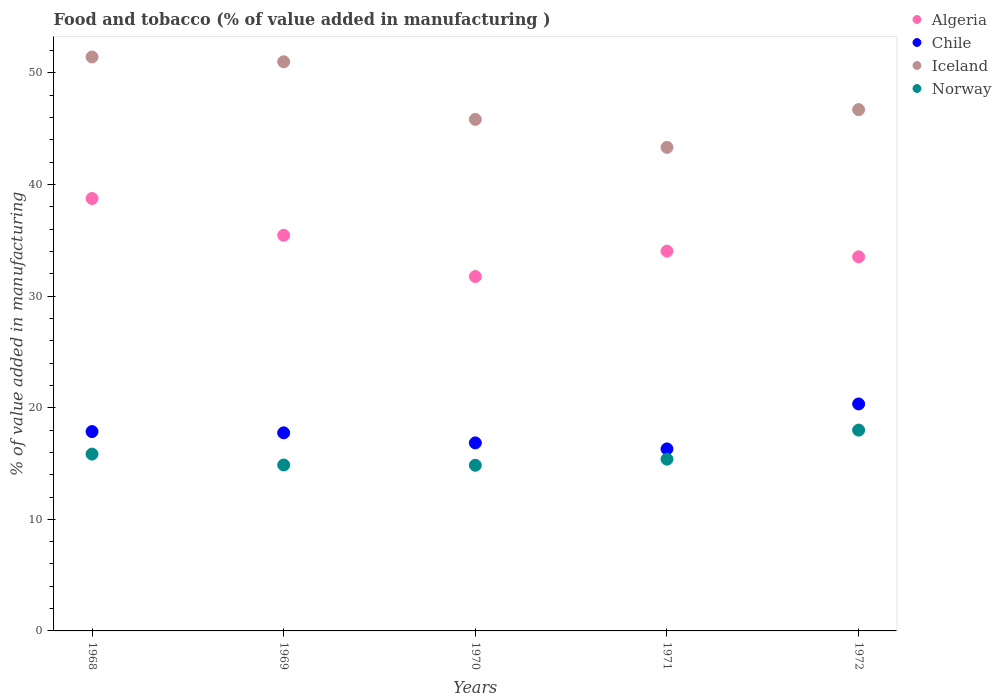What is the value added in manufacturing food and tobacco in Algeria in 1969?
Provide a short and direct response. 35.46. Across all years, what is the maximum value added in manufacturing food and tobacco in Norway?
Offer a terse response. 18. Across all years, what is the minimum value added in manufacturing food and tobacco in Norway?
Your answer should be very brief. 14.84. In which year was the value added in manufacturing food and tobacco in Chile maximum?
Offer a very short reply. 1972. What is the total value added in manufacturing food and tobacco in Norway in the graph?
Ensure brevity in your answer.  78.95. What is the difference between the value added in manufacturing food and tobacco in Algeria in 1969 and that in 1971?
Your answer should be very brief. 1.42. What is the difference between the value added in manufacturing food and tobacco in Iceland in 1972 and the value added in manufacturing food and tobacco in Norway in 1968?
Give a very brief answer. 30.87. What is the average value added in manufacturing food and tobacco in Iceland per year?
Ensure brevity in your answer.  47.67. In the year 1968, what is the difference between the value added in manufacturing food and tobacco in Algeria and value added in manufacturing food and tobacco in Norway?
Keep it short and to the point. 22.9. In how many years, is the value added in manufacturing food and tobacco in Norway greater than 26 %?
Your answer should be compact. 0. What is the ratio of the value added in manufacturing food and tobacco in Chile in 1968 to that in 1971?
Your answer should be compact. 1.1. Is the difference between the value added in manufacturing food and tobacco in Algeria in 1969 and 1970 greater than the difference between the value added in manufacturing food and tobacco in Norway in 1969 and 1970?
Your answer should be very brief. Yes. What is the difference between the highest and the second highest value added in manufacturing food and tobacco in Algeria?
Your answer should be very brief. 3.29. What is the difference between the highest and the lowest value added in manufacturing food and tobacco in Iceland?
Give a very brief answer. 8.1. In how many years, is the value added in manufacturing food and tobacco in Norway greater than the average value added in manufacturing food and tobacco in Norway taken over all years?
Your answer should be very brief. 2. Is the sum of the value added in manufacturing food and tobacco in Algeria in 1968 and 1969 greater than the maximum value added in manufacturing food and tobacco in Norway across all years?
Keep it short and to the point. Yes. Is it the case that in every year, the sum of the value added in manufacturing food and tobacco in Chile and value added in manufacturing food and tobacco in Iceland  is greater than the sum of value added in manufacturing food and tobacco in Norway and value added in manufacturing food and tobacco in Algeria?
Ensure brevity in your answer.  Yes. Is it the case that in every year, the sum of the value added in manufacturing food and tobacco in Norway and value added in manufacturing food and tobacco in Chile  is greater than the value added in manufacturing food and tobacco in Iceland?
Give a very brief answer. No. Does the value added in manufacturing food and tobacco in Algeria monotonically increase over the years?
Offer a terse response. No. Is the value added in manufacturing food and tobacco in Iceland strictly greater than the value added in manufacturing food and tobacco in Chile over the years?
Provide a succinct answer. Yes. Are the values on the major ticks of Y-axis written in scientific E-notation?
Provide a succinct answer. No. Does the graph contain any zero values?
Keep it short and to the point. No. Does the graph contain grids?
Your answer should be compact. No. Where does the legend appear in the graph?
Provide a succinct answer. Top right. What is the title of the graph?
Provide a succinct answer. Food and tobacco (% of value added in manufacturing ). What is the label or title of the X-axis?
Keep it short and to the point. Years. What is the label or title of the Y-axis?
Ensure brevity in your answer.  % of value added in manufacturing. What is the % of value added in manufacturing of Algeria in 1968?
Ensure brevity in your answer.  38.75. What is the % of value added in manufacturing in Chile in 1968?
Your response must be concise. 17.87. What is the % of value added in manufacturing of Iceland in 1968?
Keep it short and to the point. 51.43. What is the % of value added in manufacturing of Norway in 1968?
Give a very brief answer. 15.85. What is the % of value added in manufacturing of Algeria in 1969?
Your response must be concise. 35.46. What is the % of value added in manufacturing of Chile in 1969?
Offer a very short reply. 17.75. What is the % of value added in manufacturing in Iceland in 1969?
Keep it short and to the point. 51. What is the % of value added in manufacturing in Norway in 1969?
Give a very brief answer. 14.87. What is the % of value added in manufacturing in Algeria in 1970?
Your response must be concise. 31.76. What is the % of value added in manufacturing in Chile in 1970?
Your answer should be very brief. 16.85. What is the % of value added in manufacturing of Iceland in 1970?
Give a very brief answer. 45.84. What is the % of value added in manufacturing of Norway in 1970?
Make the answer very short. 14.84. What is the % of value added in manufacturing of Algeria in 1971?
Make the answer very short. 34.04. What is the % of value added in manufacturing of Chile in 1971?
Give a very brief answer. 16.31. What is the % of value added in manufacturing of Iceland in 1971?
Offer a very short reply. 43.33. What is the % of value added in manufacturing in Norway in 1971?
Your answer should be compact. 15.39. What is the % of value added in manufacturing in Algeria in 1972?
Ensure brevity in your answer.  33.52. What is the % of value added in manufacturing in Chile in 1972?
Your response must be concise. 20.34. What is the % of value added in manufacturing of Iceland in 1972?
Your response must be concise. 46.72. What is the % of value added in manufacturing of Norway in 1972?
Keep it short and to the point. 18. Across all years, what is the maximum % of value added in manufacturing in Algeria?
Provide a succinct answer. 38.75. Across all years, what is the maximum % of value added in manufacturing in Chile?
Provide a short and direct response. 20.34. Across all years, what is the maximum % of value added in manufacturing of Iceland?
Provide a short and direct response. 51.43. Across all years, what is the maximum % of value added in manufacturing in Norway?
Your answer should be very brief. 18. Across all years, what is the minimum % of value added in manufacturing of Algeria?
Your answer should be very brief. 31.76. Across all years, what is the minimum % of value added in manufacturing in Chile?
Provide a short and direct response. 16.31. Across all years, what is the minimum % of value added in manufacturing of Iceland?
Make the answer very short. 43.33. Across all years, what is the minimum % of value added in manufacturing in Norway?
Ensure brevity in your answer.  14.84. What is the total % of value added in manufacturing in Algeria in the graph?
Make the answer very short. 173.52. What is the total % of value added in manufacturing in Chile in the graph?
Offer a very short reply. 89.12. What is the total % of value added in manufacturing in Iceland in the graph?
Offer a very short reply. 238.33. What is the total % of value added in manufacturing of Norway in the graph?
Give a very brief answer. 78.95. What is the difference between the % of value added in manufacturing in Algeria in 1968 and that in 1969?
Provide a short and direct response. 3.29. What is the difference between the % of value added in manufacturing in Chile in 1968 and that in 1969?
Ensure brevity in your answer.  0.11. What is the difference between the % of value added in manufacturing in Iceland in 1968 and that in 1969?
Provide a succinct answer. 0.43. What is the difference between the % of value added in manufacturing of Norway in 1968 and that in 1969?
Offer a very short reply. 0.98. What is the difference between the % of value added in manufacturing in Algeria in 1968 and that in 1970?
Your response must be concise. 6.99. What is the difference between the % of value added in manufacturing in Chile in 1968 and that in 1970?
Keep it short and to the point. 1.01. What is the difference between the % of value added in manufacturing of Iceland in 1968 and that in 1970?
Offer a terse response. 5.59. What is the difference between the % of value added in manufacturing in Norway in 1968 and that in 1970?
Ensure brevity in your answer.  1. What is the difference between the % of value added in manufacturing of Algeria in 1968 and that in 1971?
Provide a short and direct response. 4.71. What is the difference between the % of value added in manufacturing of Chile in 1968 and that in 1971?
Offer a terse response. 1.55. What is the difference between the % of value added in manufacturing in Iceland in 1968 and that in 1971?
Provide a succinct answer. 8.1. What is the difference between the % of value added in manufacturing in Norway in 1968 and that in 1971?
Your answer should be very brief. 0.45. What is the difference between the % of value added in manufacturing in Algeria in 1968 and that in 1972?
Give a very brief answer. 5.23. What is the difference between the % of value added in manufacturing in Chile in 1968 and that in 1972?
Your response must be concise. -2.48. What is the difference between the % of value added in manufacturing of Iceland in 1968 and that in 1972?
Offer a terse response. 4.72. What is the difference between the % of value added in manufacturing of Norway in 1968 and that in 1972?
Provide a succinct answer. -2.15. What is the difference between the % of value added in manufacturing in Algeria in 1969 and that in 1970?
Your response must be concise. 3.7. What is the difference between the % of value added in manufacturing in Chile in 1969 and that in 1970?
Your response must be concise. 0.9. What is the difference between the % of value added in manufacturing of Iceland in 1969 and that in 1970?
Provide a succinct answer. 5.16. What is the difference between the % of value added in manufacturing in Norway in 1969 and that in 1970?
Make the answer very short. 0.03. What is the difference between the % of value added in manufacturing of Algeria in 1969 and that in 1971?
Keep it short and to the point. 1.42. What is the difference between the % of value added in manufacturing in Chile in 1969 and that in 1971?
Provide a short and direct response. 1.44. What is the difference between the % of value added in manufacturing in Iceland in 1969 and that in 1971?
Offer a very short reply. 7.67. What is the difference between the % of value added in manufacturing in Norway in 1969 and that in 1971?
Keep it short and to the point. -0.52. What is the difference between the % of value added in manufacturing of Algeria in 1969 and that in 1972?
Your answer should be compact. 1.93. What is the difference between the % of value added in manufacturing of Chile in 1969 and that in 1972?
Provide a succinct answer. -2.59. What is the difference between the % of value added in manufacturing of Iceland in 1969 and that in 1972?
Provide a short and direct response. 4.29. What is the difference between the % of value added in manufacturing in Norway in 1969 and that in 1972?
Keep it short and to the point. -3.12. What is the difference between the % of value added in manufacturing in Algeria in 1970 and that in 1971?
Your response must be concise. -2.28. What is the difference between the % of value added in manufacturing of Chile in 1970 and that in 1971?
Provide a short and direct response. 0.54. What is the difference between the % of value added in manufacturing in Iceland in 1970 and that in 1971?
Ensure brevity in your answer.  2.51. What is the difference between the % of value added in manufacturing of Norway in 1970 and that in 1971?
Provide a succinct answer. -0.55. What is the difference between the % of value added in manufacturing in Algeria in 1970 and that in 1972?
Provide a short and direct response. -1.76. What is the difference between the % of value added in manufacturing in Chile in 1970 and that in 1972?
Ensure brevity in your answer.  -3.49. What is the difference between the % of value added in manufacturing in Iceland in 1970 and that in 1972?
Make the answer very short. -0.88. What is the difference between the % of value added in manufacturing in Norway in 1970 and that in 1972?
Your answer should be very brief. -3.15. What is the difference between the % of value added in manufacturing in Algeria in 1971 and that in 1972?
Give a very brief answer. 0.51. What is the difference between the % of value added in manufacturing of Chile in 1971 and that in 1972?
Provide a succinct answer. -4.03. What is the difference between the % of value added in manufacturing of Iceland in 1971 and that in 1972?
Provide a succinct answer. -3.38. What is the difference between the % of value added in manufacturing in Norway in 1971 and that in 1972?
Offer a terse response. -2.6. What is the difference between the % of value added in manufacturing of Algeria in 1968 and the % of value added in manufacturing of Chile in 1969?
Your answer should be compact. 21. What is the difference between the % of value added in manufacturing of Algeria in 1968 and the % of value added in manufacturing of Iceland in 1969?
Your answer should be very brief. -12.25. What is the difference between the % of value added in manufacturing in Algeria in 1968 and the % of value added in manufacturing in Norway in 1969?
Give a very brief answer. 23.88. What is the difference between the % of value added in manufacturing of Chile in 1968 and the % of value added in manufacturing of Iceland in 1969?
Ensure brevity in your answer.  -33.14. What is the difference between the % of value added in manufacturing in Chile in 1968 and the % of value added in manufacturing in Norway in 1969?
Your response must be concise. 3. What is the difference between the % of value added in manufacturing in Iceland in 1968 and the % of value added in manufacturing in Norway in 1969?
Provide a short and direct response. 36.56. What is the difference between the % of value added in manufacturing of Algeria in 1968 and the % of value added in manufacturing of Chile in 1970?
Your response must be concise. 21.9. What is the difference between the % of value added in manufacturing of Algeria in 1968 and the % of value added in manufacturing of Iceland in 1970?
Ensure brevity in your answer.  -7.09. What is the difference between the % of value added in manufacturing in Algeria in 1968 and the % of value added in manufacturing in Norway in 1970?
Your response must be concise. 23.9. What is the difference between the % of value added in manufacturing in Chile in 1968 and the % of value added in manufacturing in Iceland in 1970?
Offer a terse response. -27.97. What is the difference between the % of value added in manufacturing of Chile in 1968 and the % of value added in manufacturing of Norway in 1970?
Offer a very short reply. 3.02. What is the difference between the % of value added in manufacturing in Iceland in 1968 and the % of value added in manufacturing in Norway in 1970?
Give a very brief answer. 36.59. What is the difference between the % of value added in manufacturing of Algeria in 1968 and the % of value added in manufacturing of Chile in 1971?
Provide a short and direct response. 22.44. What is the difference between the % of value added in manufacturing in Algeria in 1968 and the % of value added in manufacturing in Iceland in 1971?
Your answer should be compact. -4.58. What is the difference between the % of value added in manufacturing of Algeria in 1968 and the % of value added in manufacturing of Norway in 1971?
Provide a succinct answer. 23.36. What is the difference between the % of value added in manufacturing in Chile in 1968 and the % of value added in manufacturing in Iceland in 1971?
Make the answer very short. -25.47. What is the difference between the % of value added in manufacturing in Chile in 1968 and the % of value added in manufacturing in Norway in 1971?
Offer a terse response. 2.47. What is the difference between the % of value added in manufacturing in Iceland in 1968 and the % of value added in manufacturing in Norway in 1971?
Your response must be concise. 36.04. What is the difference between the % of value added in manufacturing in Algeria in 1968 and the % of value added in manufacturing in Chile in 1972?
Offer a terse response. 18.41. What is the difference between the % of value added in manufacturing of Algeria in 1968 and the % of value added in manufacturing of Iceland in 1972?
Your answer should be compact. -7.97. What is the difference between the % of value added in manufacturing of Algeria in 1968 and the % of value added in manufacturing of Norway in 1972?
Keep it short and to the point. 20.75. What is the difference between the % of value added in manufacturing of Chile in 1968 and the % of value added in manufacturing of Iceland in 1972?
Make the answer very short. -28.85. What is the difference between the % of value added in manufacturing of Chile in 1968 and the % of value added in manufacturing of Norway in 1972?
Offer a terse response. -0.13. What is the difference between the % of value added in manufacturing in Iceland in 1968 and the % of value added in manufacturing in Norway in 1972?
Your answer should be very brief. 33.44. What is the difference between the % of value added in manufacturing in Algeria in 1969 and the % of value added in manufacturing in Chile in 1970?
Your answer should be compact. 18.61. What is the difference between the % of value added in manufacturing in Algeria in 1969 and the % of value added in manufacturing in Iceland in 1970?
Your response must be concise. -10.38. What is the difference between the % of value added in manufacturing in Algeria in 1969 and the % of value added in manufacturing in Norway in 1970?
Provide a succinct answer. 20.61. What is the difference between the % of value added in manufacturing of Chile in 1969 and the % of value added in manufacturing of Iceland in 1970?
Offer a very short reply. -28.09. What is the difference between the % of value added in manufacturing in Chile in 1969 and the % of value added in manufacturing in Norway in 1970?
Provide a short and direct response. 2.91. What is the difference between the % of value added in manufacturing of Iceland in 1969 and the % of value added in manufacturing of Norway in 1970?
Provide a short and direct response. 36.16. What is the difference between the % of value added in manufacturing in Algeria in 1969 and the % of value added in manufacturing in Chile in 1971?
Your answer should be compact. 19.15. What is the difference between the % of value added in manufacturing of Algeria in 1969 and the % of value added in manufacturing of Iceland in 1971?
Offer a terse response. -7.88. What is the difference between the % of value added in manufacturing of Algeria in 1969 and the % of value added in manufacturing of Norway in 1971?
Your answer should be compact. 20.07. What is the difference between the % of value added in manufacturing in Chile in 1969 and the % of value added in manufacturing in Iceland in 1971?
Keep it short and to the point. -25.58. What is the difference between the % of value added in manufacturing in Chile in 1969 and the % of value added in manufacturing in Norway in 1971?
Provide a short and direct response. 2.36. What is the difference between the % of value added in manufacturing in Iceland in 1969 and the % of value added in manufacturing in Norway in 1971?
Your response must be concise. 35.61. What is the difference between the % of value added in manufacturing in Algeria in 1969 and the % of value added in manufacturing in Chile in 1972?
Make the answer very short. 15.12. What is the difference between the % of value added in manufacturing of Algeria in 1969 and the % of value added in manufacturing of Iceland in 1972?
Your answer should be compact. -11.26. What is the difference between the % of value added in manufacturing of Algeria in 1969 and the % of value added in manufacturing of Norway in 1972?
Offer a terse response. 17.46. What is the difference between the % of value added in manufacturing in Chile in 1969 and the % of value added in manufacturing in Iceland in 1972?
Keep it short and to the point. -28.96. What is the difference between the % of value added in manufacturing in Chile in 1969 and the % of value added in manufacturing in Norway in 1972?
Your answer should be very brief. -0.24. What is the difference between the % of value added in manufacturing of Iceland in 1969 and the % of value added in manufacturing of Norway in 1972?
Make the answer very short. 33.01. What is the difference between the % of value added in manufacturing in Algeria in 1970 and the % of value added in manufacturing in Chile in 1971?
Keep it short and to the point. 15.45. What is the difference between the % of value added in manufacturing in Algeria in 1970 and the % of value added in manufacturing in Iceland in 1971?
Offer a terse response. -11.58. What is the difference between the % of value added in manufacturing in Algeria in 1970 and the % of value added in manufacturing in Norway in 1971?
Your response must be concise. 16.37. What is the difference between the % of value added in manufacturing in Chile in 1970 and the % of value added in manufacturing in Iceland in 1971?
Provide a short and direct response. -26.48. What is the difference between the % of value added in manufacturing of Chile in 1970 and the % of value added in manufacturing of Norway in 1971?
Your answer should be compact. 1.46. What is the difference between the % of value added in manufacturing of Iceland in 1970 and the % of value added in manufacturing of Norway in 1971?
Give a very brief answer. 30.45. What is the difference between the % of value added in manufacturing of Algeria in 1970 and the % of value added in manufacturing of Chile in 1972?
Offer a very short reply. 11.42. What is the difference between the % of value added in manufacturing in Algeria in 1970 and the % of value added in manufacturing in Iceland in 1972?
Your answer should be compact. -14.96. What is the difference between the % of value added in manufacturing in Algeria in 1970 and the % of value added in manufacturing in Norway in 1972?
Offer a very short reply. 13.76. What is the difference between the % of value added in manufacturing of Chile in 1970 and the % of value added in manufacturing of Iceland in 1972?
Your answer should be compact. -29.86. What is the difference between the % of value added in manufacturing in Chile in 1970 and the % of value added in manufacturing in Norway in 1972?
Provide a short and direct response. -1.14. What is the difference between the % of value added in manufacturing of Iceland in 1970 and the % of value added in manufacturing of Norway in 1972?
Provide a short and direct response. 27.85. What is the difference between the % of value added in manufacturing in Algeria in 1971 and the % of value added in manufacturing in Chile in 1972?
Your response must be concise. 13.69. What is the difference between the % of value added in manufacturing of Algeria in 1971 and the % of value added in manufacturing of Iceland in 1972?
Your response must be concise. -12.68. What is the difference between the % of value added in manufacturing in Algeria in 1971 and the % of value added in manufacturing in Norway in 1972?
Keep it short and to the point. 16.04. What is the difference between the % of value added in manufacturing in Chile in 1971 and the % of value added in manufacturing in Iceland in 1972?
Your response must be concise. -30.4. What is the difference between the % of value added in manufacturing in Chile in 1971 and the % of value added in manufacturing in Norway in 1972?
Ensure brevity in your answer.  -1.68. What is the difference between the % of value added in manufacturing of Iceland in 1971 and the % of value added in manufacturing of Norway in 1972?
Offer a very short reply. 25.34. What is the average % of value added in manufacturing of Algeria per year?
Provide a succinct answer. 34.7. What is the average % of value added in manufacturing of Chile per year?
Ensure brevity in your answer.  17.82. What is the average % of value added in manufacturing in Iceland per year?
Give a very brief answer. 47.67. What is the average % of value added in manufacturing of Norway per year?
Your answer should be compact. 15.79. In the year 1968, what is the difference between the % of value added in manufacturing of Algeria and % of value added in manufacturing of Chile?
Your answer should be compact. 20.88. In the year 1968, what is the difference between the % of value added in manufacturing in Algeria and % of value added in manufacturing in Iceland?
Give a very brief answer. -12.68. In the year 1968, what is the difference between the % of value added in manufacturing of Algeria and % of value added in manufacturing of Norway?
Provide a short and direct response. 22.9. In the year 1968, what is the difference between the % of value added in manufacturing in Chile and % of value added in manufacturing in Iceland?
Offer a terse response. -33.57. In the year 1968, what is the difference between the % of value added in manufacturing in Chile and % of value added in manufacturing in Norway?
Provide a short and direct response. 2.02. In the year 1968, what is the difference between the % of value added in manufacturing in Iceland and % of value added in manufacturing in Norway?
Offer a very short reply. 35.59. In the year 1969, what is the difference between the % of value added in manufacturing of Algeria and % of value added in manufacturing of Chile?
Keep it short and to the point. 17.71. In the year 1969, what is the difference between the % of value added in manufacturing of Algeria and % of value added in manufacturing of Iceland?
Your answer should be very brief. -15.55. In the year 1969, what is the difference between the % of value added in manufacturing in Algeria and % of value added in manufacturing in Norway?
Provide a short and direct response. 20.59. In the year 1969, what is the difference between the % of value added in manufacturing of Chile and % of value added in manufacturing of Iceland?
Ensure brevity in your answer.  -33.25. In the year 1969, what is the difference between the % of value added in manufacturing in Chile and % of value added in manufacturing in Norway?
Your response must be concise. 2.88. In the year 1969, what is the difference between the % of value added in manufacturing of Iceland and % of value added in manufacturing of Norway?
Your answer should be compact. 36.13. In the year 1970, what is the difference between the % of value added in manufacturing in Algeria and % of value added in manufacturing in Chile?
Your answer should be very brief. 14.91. In the year 1970, what is the difference between the % of value added in manufacturing in Algeria and % of value added in manufacturing in Iceland?
Provide a short and direct response. -14.08. In the year 1970, what is the difference between the % of value added in manufacturing in Algeria and % of value added in manufacturing in Norway?
Provide a succinct answer. 16.91. In the year 1970, what is the difference between the % of value added in manufacturing of Chile and % of value added in manufacturing of Iceland?
Provide a succinct answer. -28.99. In the year 1970, what is the difference between the % of value added in manufacturing of Chile and % of value added in manufacturing of Norway?
Your answer should be compact. 2.01. In the year 1970, what is the difference between the % of value added in manufacturing in Iceland and % of value added in manufacturing in Norway?
Provide a short and direct response. 31. In the year 1971, what is the difference between the % of value added in manufacturing of Algeria and % of value added in manufacturing of Chile?
Give a very brief answer. 17.72. In the year 1971, what is the difference between the % of value added in manufacturing in Algeria and % of value added in manufacturing in Iceland?
Your answer should be very brief. -9.3. In the year 1971, what is the difference between the % of value added in manufacturing in Algeria and % of value added in manufacturing in Norway?
Ensure brevity in your answer.  18.64. In the year 1971, what is the difference between the % of value added in manufacturing in Chile and % of value added in manufacturing in Iceland?
Your answer should be compact. -27.02. In the year 1971, what is the difference between the % of value added in manufacturing of Iceland and % of value added in manufacturing of Norway?
Your answer should be very brief. 27.94. In the year 1972, what is the difference between the % of value added in manufacturing in Algeria and % of value added in manufacturing in Chile?
Provide a short and direct response. 13.18. In the year 1972, what is the difference between the % of value added in manufacturing of Algeria and % of value added in manufacturing of Iceland?
Your response must be concise. -13.19. In the year 1972, what is the difference between the % of value added in manufacturing in Algeria and % of value added in manufacturing in Norway?
Ensure brevity in your answer.  15.53. In the year 1972, what is the difference between the % of value added in manufacturing of Chile and % of value added in manufacturing of Iceland?
Offer a very short reply. -26.37. In the year 1972, what is the difference between the % of value added in manufacturing of Chile and % of value added in manufacturing of Norway?
Your response must be concise. 2.35. In the year 1972, what is the difference between the % of value added in manufacturing of Iceland and % of value added in manufacturing of Norway?
Ensure brevity in your answer.  28.72. What is the ratio of the % of value added in manufacturing in Algeria in 1968 to that in 1969?
Keep it short and to the point. 1.09. What is the ratio of the % of value added in manufacturing in Chile in 1968 to that in 1969?
Ensure brevity in your answer.  1.01. What is the ratio of the % of value added in manufacturing of Iceland in 1968 to that in 1969?
Offer a terse response. 1.01. What is the ratio of the % of value added in manufacturing in Norway in 1968 to that in 1969?
Make the answer very short. 1.07. What is the ratio of the % of value added in manufacturing of Algeria in 1968 to that in 1970?
Give a very brief answer. 1.22. What is the ratio of the % of value added in manufacturing of Chile in 1968 to that in 1970?
Your answer should be very brief. 1.06. What is the ratio of the % of value added in manufacturing in Iceland in 1968 to that in 1970?
Offer a very short reply. 1.12. What is the ratio of the % of value added in manufacturing in Norway in 1968 to that in 1970?
Your answer should be compact. 1.07. What is the ratio of the % of value added in manufacturing of Algeria in 1968 to that in 1971?
Keep it short and to the point. 1.14. What is the ratio of the % of value added in manufacturing in Chile in 1968 to that in 1971?
Provide a succinct answer. 1.1. What is the ratio of the % of value added in manufacturing in Iceland in 1968 to that in 1971?
Give a very brief answer. 1.19. What is the ratio of the % of value added in manufacturing of Norway in 1968 to that in 1971?
Offer a terse response. 1.03. What is the ratio of the % of value added in manufacturing in Algeria in 1968 to that in 1972?
Offer a very short reply. 1.16. What is the ratio of the % of value added in manufacturing of Chile in 1968 to that in 1972?
Keep it short and to the point. 0.88. What is the ratio of the % of value added in manufacturing in Iceland in 1968 to that in 1972?
Ensure brevity in your answer.  1.1. What is the ratio of the % of value added in manufacturing of Norway in 1968 to that in 1972?
Offer a very short reply. 0.88. What is the ratio of the % of value added in manufacturing in Algeria in 1969 to that in 1970?
Keep it short and to the point. 1.12. What is the ratio of the % of value added in manufacturing of Chile in 1969 to that in 1970?
Make the answer very short. 1.05. What is the ratio of the % of value added in manufacturing of Iceland in 1969 to that in 1970?
Ensure brevity in your answer.  1.11. What is the ratio of the % of value added in manufacturing in Algeria in 1969 to that in 1971?
Your answer should be compact. 1.04. What is the ratio of the % of value added in manufacturing in Chile in 1969 to that in 1971?
Offer a terse response. 1.09. What is the ratio of the % of value added in manufacturing of Iceland in 1969 to that in 1971?
Give a very brief answer. 1.18. What is the ratio of the % of value added in manufacturing of Norway in 1969 to that in 1971?
Ensure brevity in your answer.  0.97. What is the ratio of the % of value added in manufacturing in Algeria in 1969 to that in 1972?
Offer a very short reply. 1.06. What is the ratio of the % of value added in manufacturing of Chile in 1969 to that in 1972?
Offer a very short reply. 0.87. What is the ratio of the % of value added in manufacturing in Iceland in 1969 to that in 1972?
Provide a succinct answer. 1.09. What is the ratio of the % of value added in manufacturing in Norway in 1969 to that in 1972?
Offer a very short reply. 0.83. What is the ratio of the % of value added in manufacturing of Algeria in 1970 to that in 1971?
Your answer should be compact. 0.93. What is the ratio of the % of value added in manufacturing of Chile in 1970 to that in 1971?
Your answer should be very brief. 1.03. What is the ratio of the % of value added in manufacturing of Iceland in 1970 to that in 1971?
Ensure brevity in your answer.  1.06. What is the ratio of the % of value added in manufacturing of Norway in 1970 to that in 1971?
Provide a short and direct response. 0.96. What is the ratio of the % of value added in manufacturing in Chile in 1970 to that in 1972?
Your answer should be compact. 0.83. What is the ratio of the % of value added in manufacturing of Iceland in 1970 to that in 1972?
Make the answer very short. 0.98. What is the ratio of the % of value added in manufacturing of Norway in 1970 to that in 1972?
Offer a very short reply. 0.82. What is the ratio of the % of value added in manufacturing of Algeria in 1971 to that in 1972?
Offer a very short reply. 1.02. What is the ratio of the % of value added in manufacturing in Chile in 1971 to that in 1972?
Provide a short and direct response. 0.8. What is the ratio of the % of value added in manufacturing in Iceland in 1971 to that in 1972?
Offer a terse response. 0.93. What is the ratio of the % of value added in manufacturing in Norway in 1971 to that in 1972?
Give a very brief answer. 0.86. What is the difference between the highest and the second highest % of value added in manufacturing of Algeria?
Provide a succinct answer. 3.29. What is the difference between the highest and the second highest % of value added in manufacturing of Chile?
Give a very brief answer. 2.48. What is the difference between the highest and the second highest % of value added in manufacturing in Iceland?
Make the answer very short. 0.43. What is the difference between the highest and the second highest % of value added in manufacturing in Norway?
Your answer should be very brief. 2.15. What is the difference between the highest and the lowest % of value added in manufacturing of Algeria?
Your response must be concise. 6.99. What is the difference between the highest and the lowest % of value added in manufacturing in Chile?
Your answer should be compact. 4.03. What is the difference between the highest and the lowest % of value added in manufacturing of Iceland?
Your response must be concise. 8.1. What is the difference between the highest and the lowest % of value added in manufacturing in Norway?
Give a very brief answer. 3.15. 